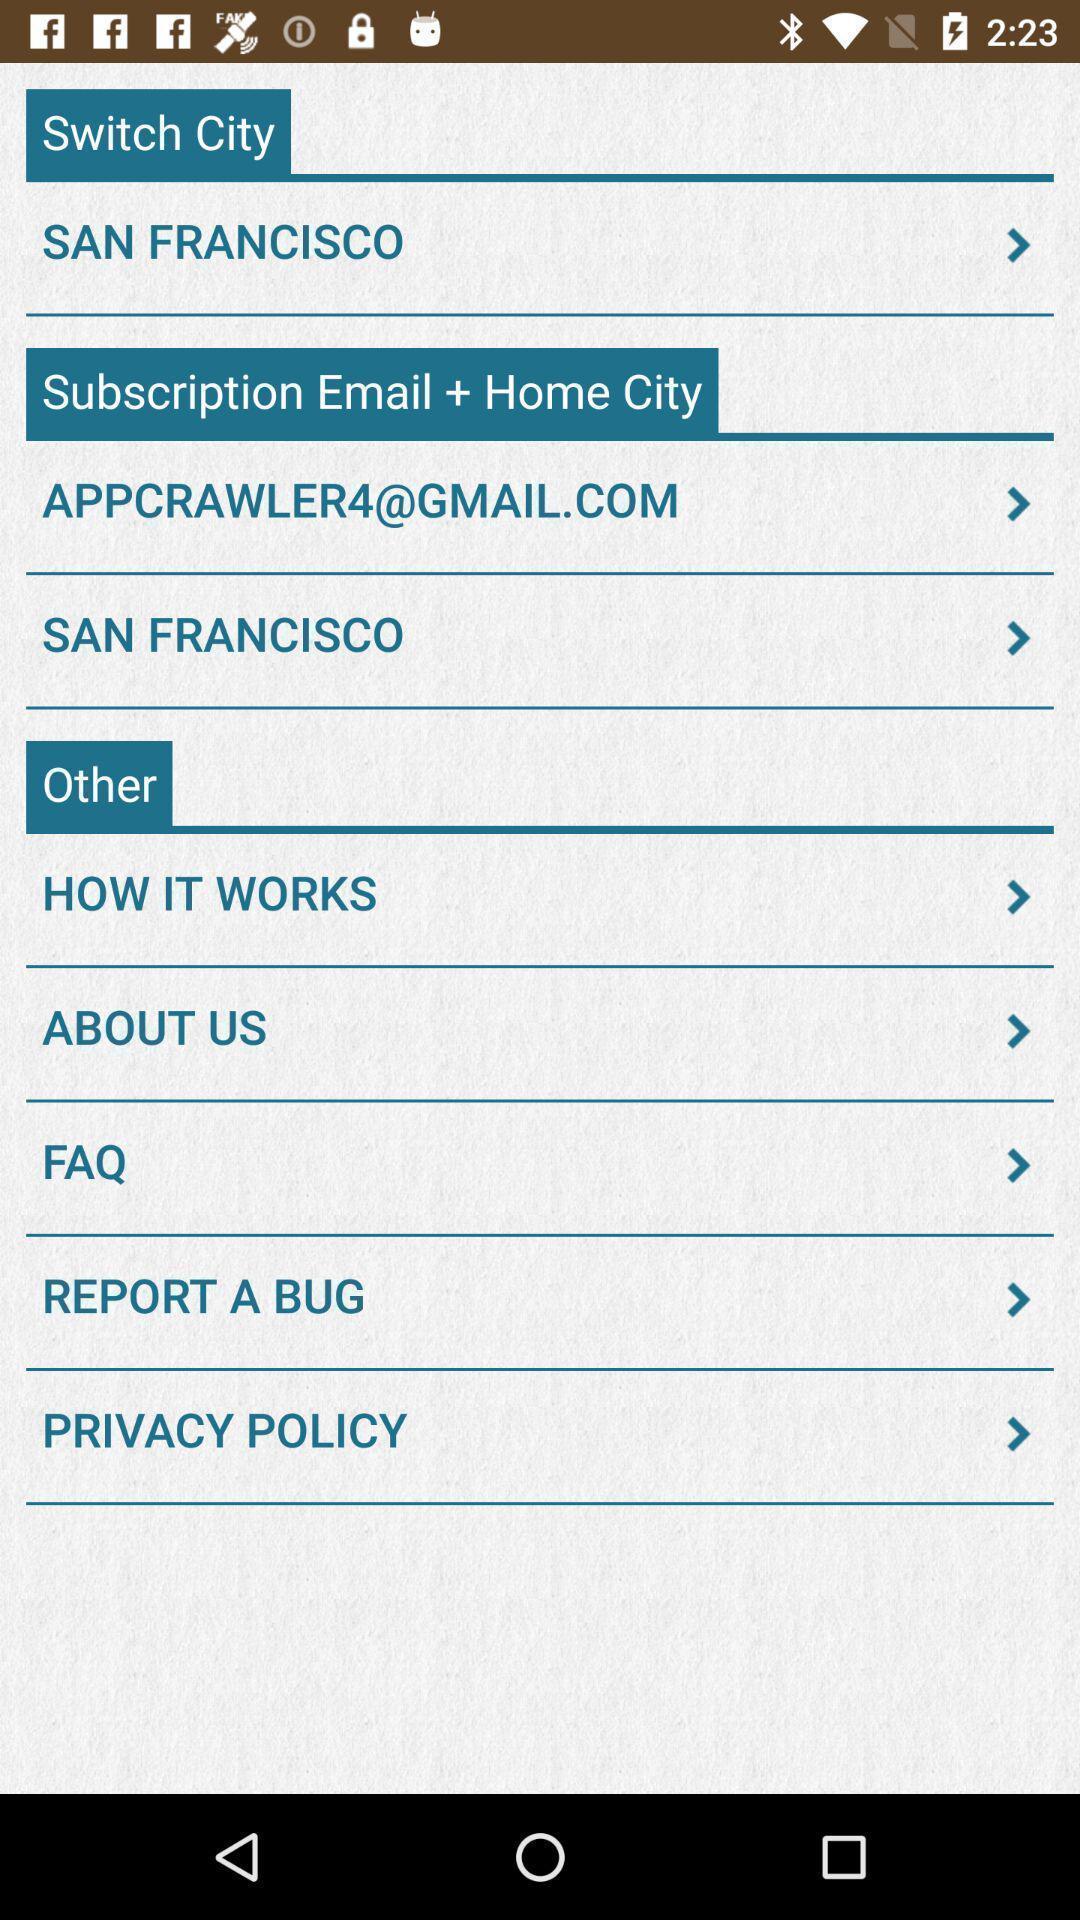Tell me what you see in this picture. Page displaying to switch cities in app. 